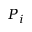<formula> <loc_0><loc_0><loc_500><loc_500>P _ { i }</formula> 